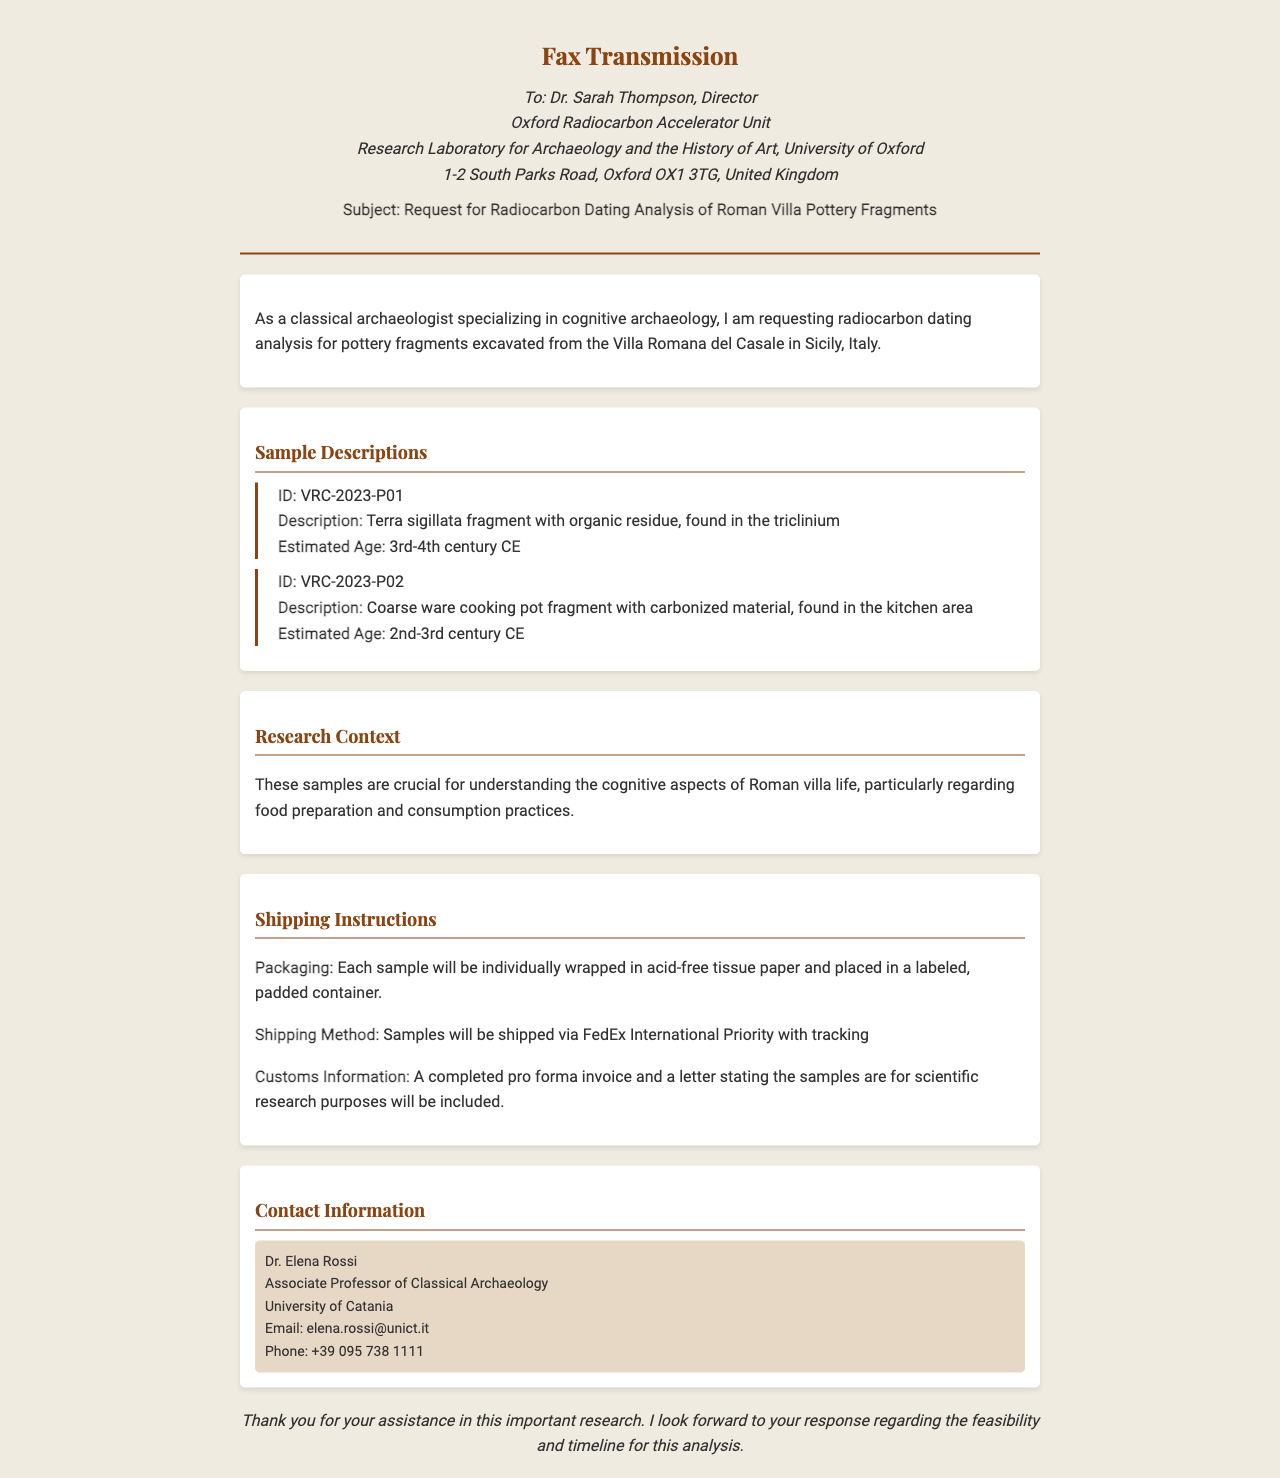What is the subject of the fax? The subject of the fax is explicitly stated in the document as a request for radiocarbon dating analysis of Roman villa pottery fragments.
Answer: Request for Radiocarbon Dating Analysis of Roman Villa Pottery Fragments Who is the recipient of the fax? The recipient of the fax is mentioned at the top of the document, identifying Dr. Sarah Thompson and her affiliated institution.
Answer: Dr. Sarah Thompson What are the two sample IDs listed in the document? The sample IDs provided in the document are VRC-2023-P01 and VRC-2023-P02.
Answer: VRC-2023-P01, VRC-2023-P02 What time period does the first sample estimated age fall into? The estimated age for the first sample is included in the description as the 3rd-4th century CE.
Answer: 3rd-4th century CE What shipping method will be used for the samples? The shipping method is specified in the shipping instructions section of the document as FedEx International Priority with tracking.
Answer: FedEx International Priority Why are the samples considered crucial? The document describes the samples as crucial for understanding cognitive aspects of Roman villa life, particularly regarding food preparation and consumption practices.
Answer: Understanding cognitive aspects of Roman villa life What is included with the samples for customs? The document states that a completed pro forma invoice and a letter stating the samples are for scientific research purposes will be included for customs.
Answer: Completed pro forma invoice and a letter Who is the contact person listed in the document? The contact information provided at the end identifies Dr. Elena Rossi as the contact person for this analysis request.
Answer: Dr. Elena Rossi 